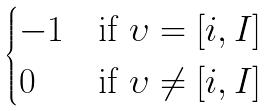<formula> <loc_0><loc_0><loc_500><loc_500>\begin{cases} - 1 & \text {if $\upsilon = [i,I]$} \\ 0 & \text {if $\upsilon \not= [i,I]$} \end{cases}</formula> 